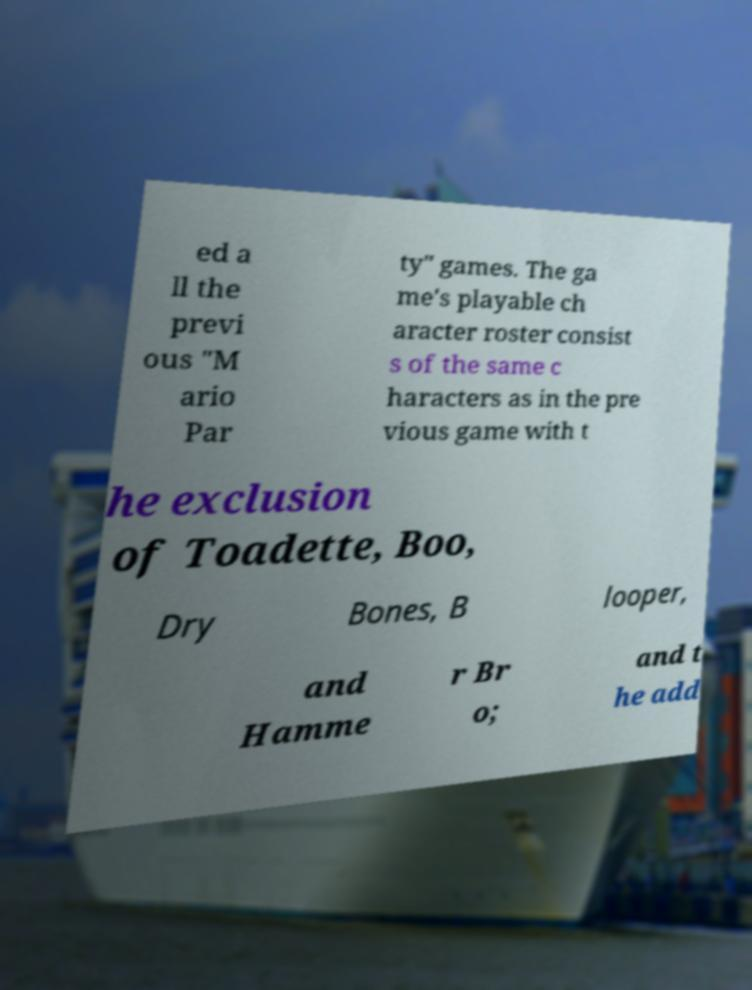Could you extract and type out the text from this image? ed a ll the previ ous "M ario Par ty" games. The ga me's playable ch aracter roster consist s of the same c haracters as in the pre vious game with t he exclusion of Toadette, Boo, Dry Bones, B looper, and Hamme r Br o; and t he add 